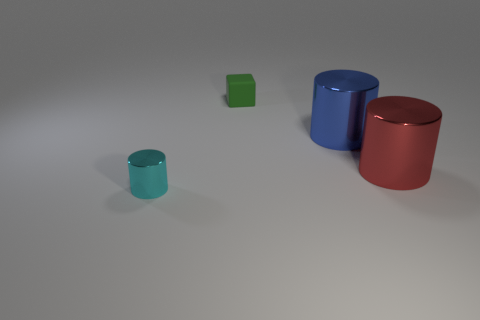Subtract all red cylinders. How many cylinders are left? 2 Add 2 cyan cylinders. How many objects exist? 6 Subtract all cubes. How many objects are left? 3 Subtract all cyan cylinders. How many cylinders are left? 2 Subtract 2 cylinders. How many cylinders are left? 1 Add 1 gray blocks. How many gray blocks exist? 1 Subtract 1 red cylinders. How many objects are left? 3 Subtract all yellow cubes. Subtract all yellow balls. How many cubes are left? 1 Subtract all purple cylinders. How many yellow cubes are left? 0 Subtract all yellow rubber objects. Subtract all large shiny cylinders. How many objects are left? 2 